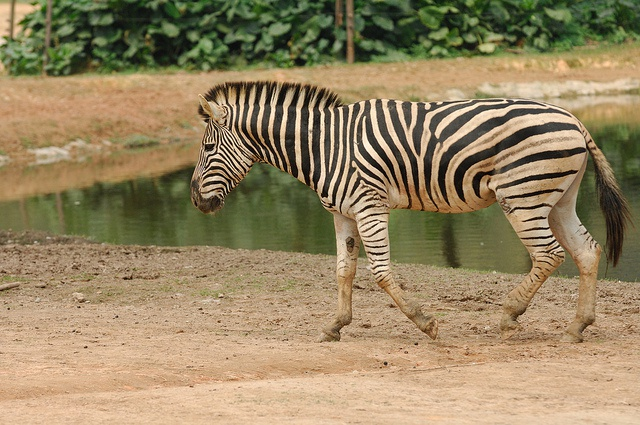Describe the objects in this image and their specific colors. I can see a zebra in olive, black, and tan tones in this image. 